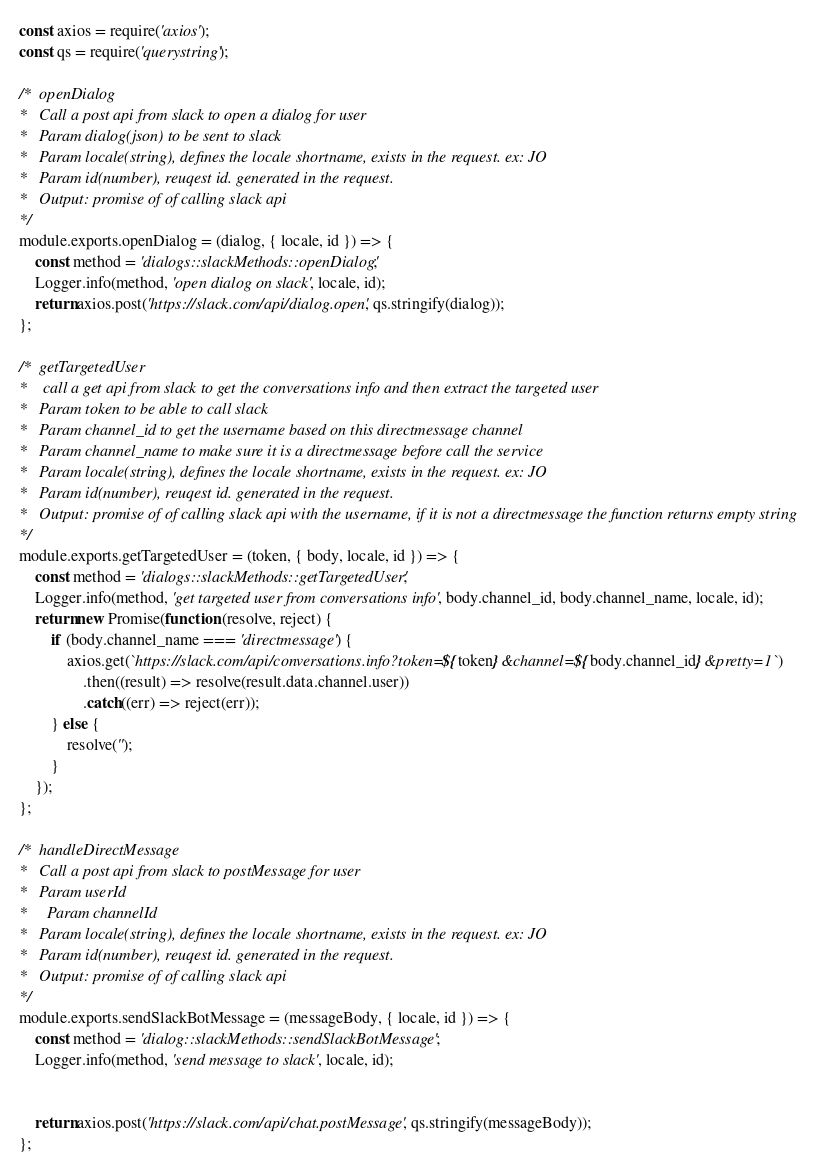<code> <loc_0><loc_0><loc_500><loc_500><_JavaScript_>const axios = require('axios');
const qs = require('querystring');

/*  openDialog
*   Call a post api from slack to open a dialog for user
*   Param dialog(json) to be sent to slack
*   Param locale(string), defines the locale shortname, exists in the request. ex: JO
*   Param id(number), reuqest id. generated in the request.
*   Output: promise of of calling slack api
*/
module.exports.openDialog = (dialog, { locale, id }) => {
	const method = 'dialogs::slackMethods::openDialog';
	Logger.info(method, 'open dialog on slack', locale, id);
	return axios.post('https://slack.com/api/dialog.open', qs.stringify(dialog));
};

/*  getTargetedUser
*    call a get api from slack to get the conversations info and then extract the targeted user
*   Param token to be able to call slack
*   Param channel_id to get the username based on this directmessage channel
*   Param channel_name to make sure it is a directmessage before call the service
*   Param locale(string), defines the locale shortname, exists in the request. ex: JO
*   Param id(number), reuqest id. generated in the request.
*   Output: promise of of calling slack api with the username, if it is not a directmessage the function returns empty string
*/
module.exports.getTargetedUser = (token, { body, locale, id }) => {
	const method = 'dialogs::slackMethods::getTargetedUser';
	Logger.info(method, 'get targeted user from conversations info', body.channel_id, body.channel_name, locale, id);
	return new Promise(function (resolve, reject) {
		if (body.channel_name === 'directmessage') {
			axios.get(`https://slack.com/api/conversations.info?token=${token}&channel=${body.channel_id}&pretty=1`)
				.then((result) => resolve(result.data.channel.user))
				.catch((err) => reject(err));
		} else {
			resolve('');
		}
	});
};

/*  handleDirectMessage
*   Call a post api from slack to postMessage for user
*   Param userId
*	  Param channelId
*   Param locale(string), defines the locale shortname, exists in the request. ex: JO
*   Param id(number), reuqest id. generated in the request.
*   Output: promise of of calling slack api
*/
module.exports.sendSlackBotMessage = (messageBody, { locale, id }) => {
	const method = 'dialog::slackMethods::sendSlackBotMessage';
	Logger.info(method, 'send message to slack', locale, id);


	return axios.post('https://slack.com/api/chat.postMessage', qs.stringify(messageBody));
};
</code> 